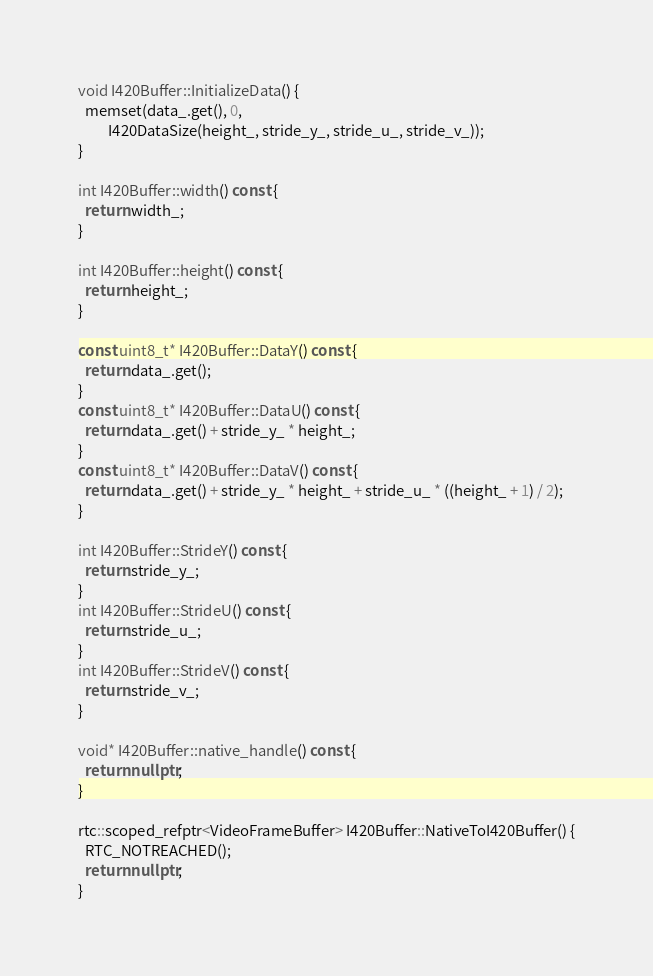<code> <loc_0><loc_0><loc_500><loc_500><_C++_>
void I420Buffer::InitializeData() {
  memset(data_.get(), 0,
         I420DataSize(height_, stride_y_, stride_u_, stride_v_));
}

int I420Buffer::width() const {
  return width_;
}

int I420Buffer::height() const {
  return height_;
}

const uint8_t* I420Buffer::DataY() const {
  return data_.get();
}
const uint8_t* I420Buffer::DataU() const {
  return data_.get() + stride_y_ * height_;
}
const uint8_t* I420Buffer::DataV() const {
  return data_.get() + stride_y_ * height_ + stride_u_ * ((height_ + 1) / 2);
}

int I420Buffer::StrideY() const {
  return stride_y_;
}
int I420Buffer::StrideU() const {
  return stride_u_;
}
int I420Buffer::StrideV() const {
  return stride_v_;
}

void* I420Buffer::native_handle() const {
  return nullptr;
}

rtc::scoped_refptr<VideoFrameBuffer> I420Buffer::NativeToI420Buffer() {
  RTC_NOTREACHED();
  return nullptr;
}
</code> 